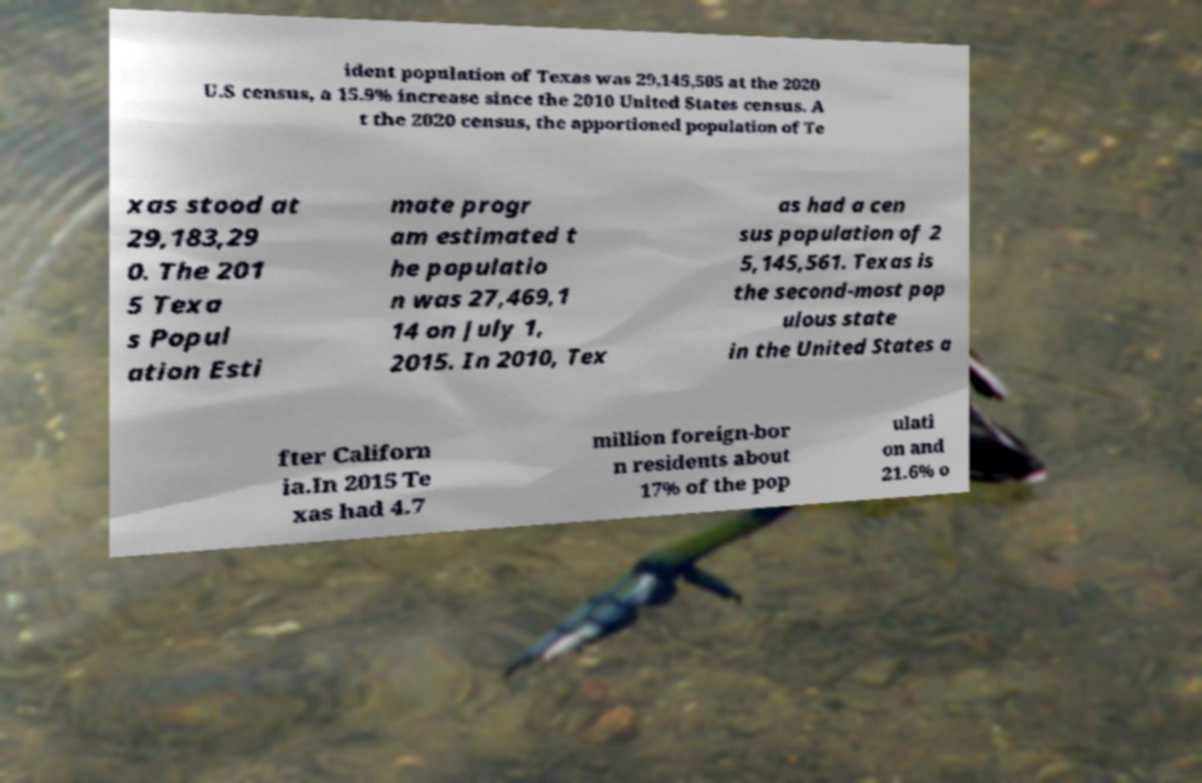Could you assist in decoding the text presented in this image and type it out clearly? ident population of Texas was 29,145,505 at the 2020 U.S census, a 15.9% increase since the 2010 United States census. A t the 2020 census, the apportioned population of Te xas stood at 29,183,29 0. The 201 5 Texa s Popul ation Esti mate progr am estimated t he populatio n was 27,469,1 14 on July 1, 2015. In 2010, Tex as had a cen sus population of 2 5,145,561. Texas is the second-most pop ulous state in the United States a fter Californ ia.In 2015 Te xas had 4.7 million foreign-bor n residents about 17% of the pop ulati on and 21.6% o 